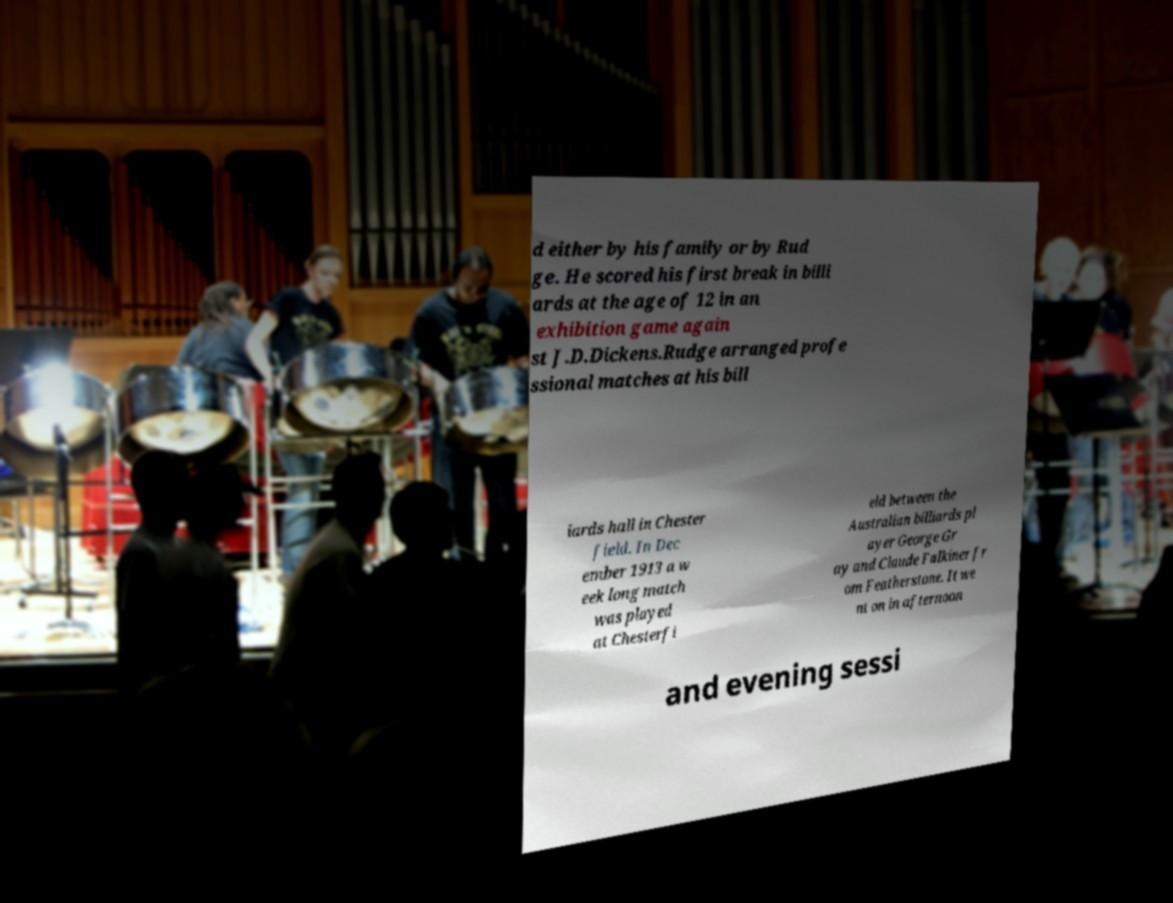For documentation purposes, I need the text within this image transcribed. Could you provide that? d either by his family or by Rud ge. He scored his first break in billi ards at the age of 12 in an exhibition game again st J.D.Dickens.Rudge arranged profe ssional matches at his bill iards hall in Chester field. In Dec ember 1913 a w eek long match was played at Chesterfi eld between the Australian billiards pl ayer George Gr ay and Claude Falkiner fr om Featherstone. It we nt on in afternoon and evening sessi 